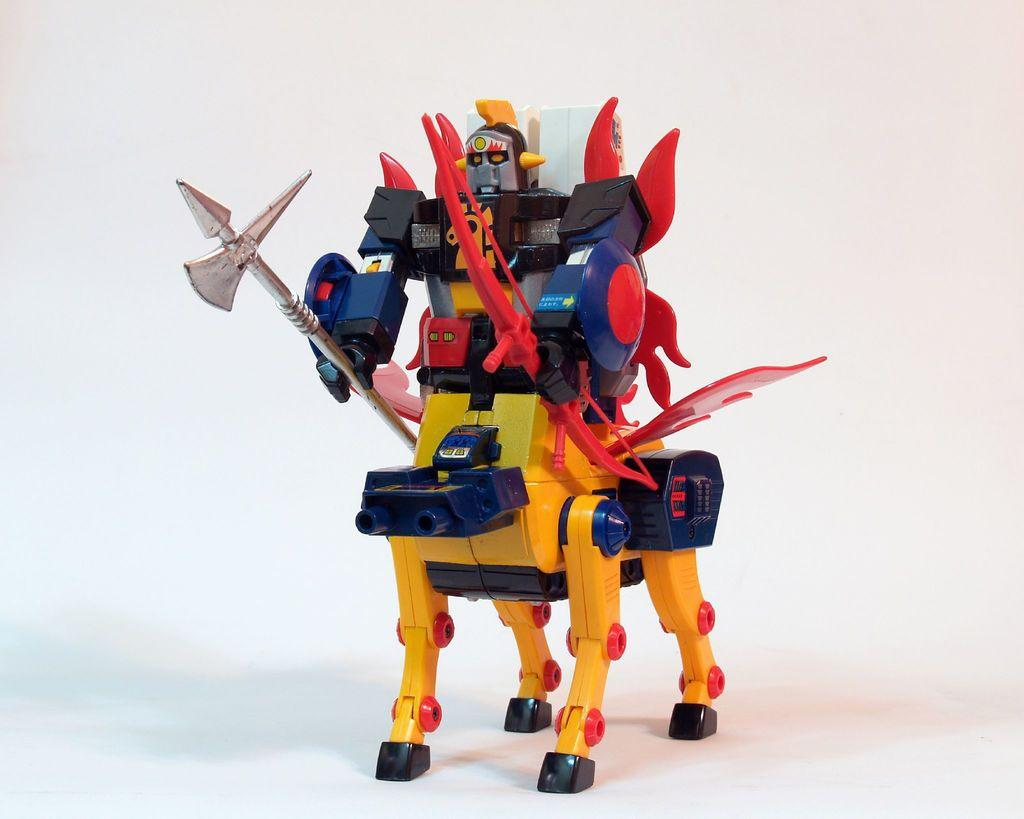What is the main subject in the center of the image? There is a robot toy in the center of the image. What is the price of the zinc in the image? There is no zinc present in the image, and therefore no price can be determined. 